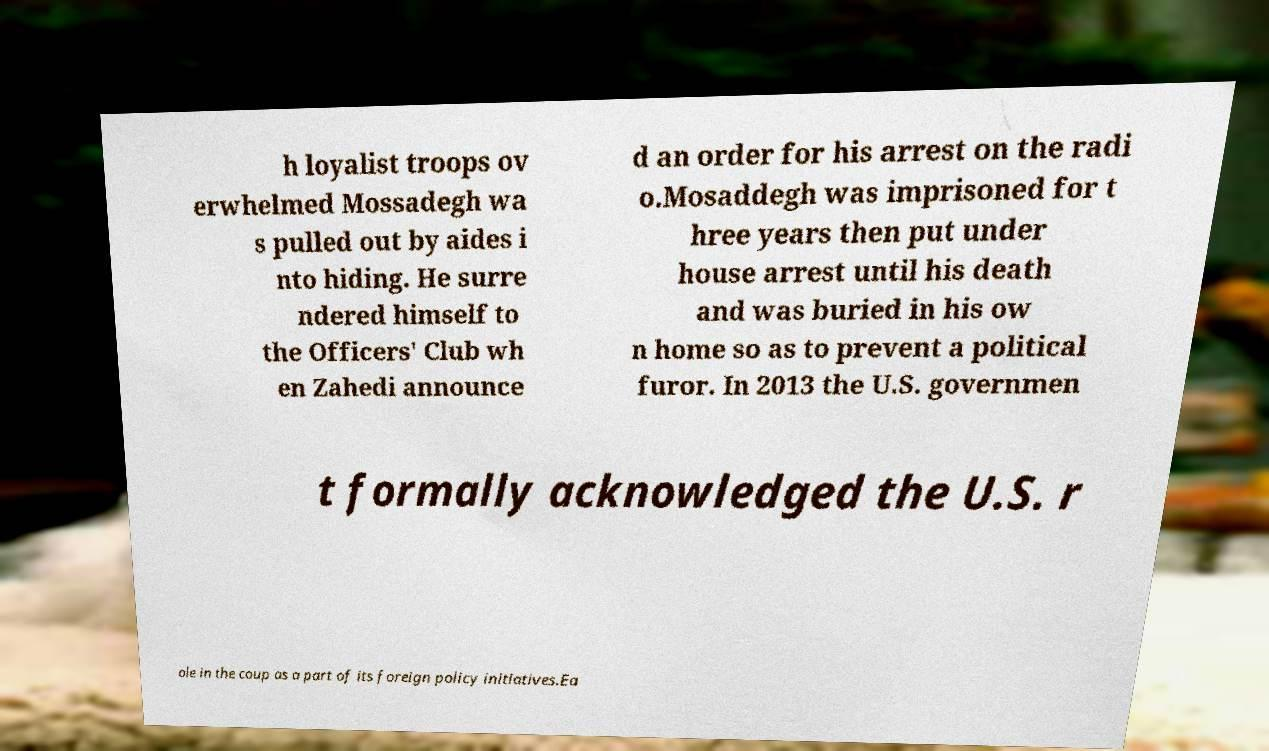What messages or text are displayed in this image? I need them in a readable, typed format. h loyalist troops ov erwhelmed Mossadegh wa s pulled out by aides i nto hiding. He surre ndered himself to the Officers' Club wh en Zahedi announce d an order for his arrest on the radi o.Mosaddegh was imprisoned for t hree years then put under house arrest until his death and was buried in his ow n home so as to prevent a political furor. In 2013 the U.S. governmen t formally acknowledged the U.S. r ole in the coup as a part of its foreign policy initiatives.Ea 